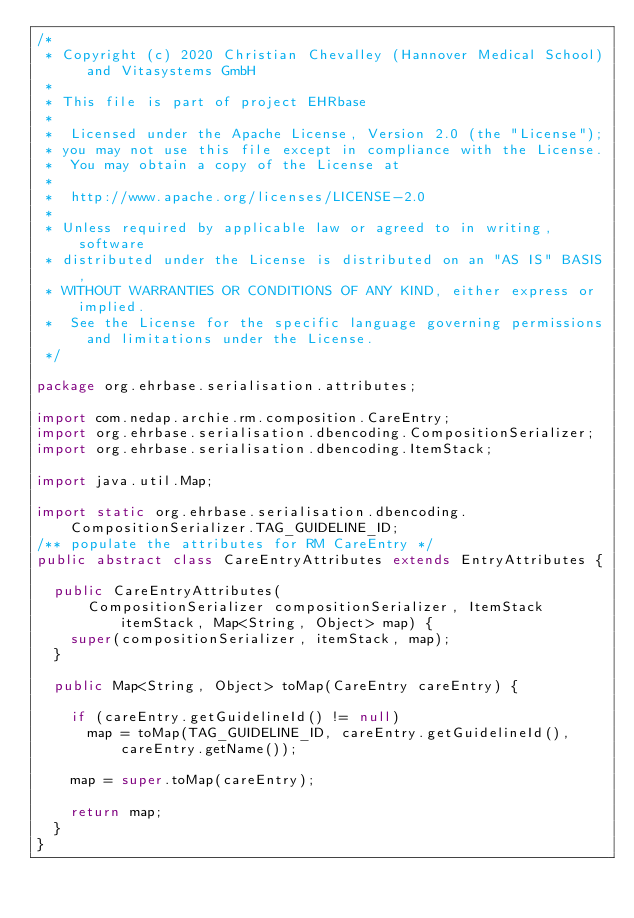<code> <loc_0><loc_0><loc_500><loc_500><_Java_>/*
 * Copyright (c) 2020 Christian Chevalley (Hannover Medical School) and Vitasystems GmbH
 *
 * This file is part of project EHRbase
 *
 *  Licensed under the Apache License, Version 2.0 (the "License");
 * you may not use this file except in compliance with the License.
 *  You may obtain a copy of the License at
 *
 *  http://www.apache.org/licenses/LICENSE-2.0
 *
 * Unless required by applicable law or agreed to in writing, software
 * distributed under the License is distributed on an "AS IS" BASIS,
 * WITHOUT WARRANTIES OR CONDITIONS OF ANY KIND, either express or implied.
 *  See the License for the specific language governing permissions and limitations under the License.
 */

package org.ehrbase.serialisation.attributes;

import com.nedap.archie.rm.composition.CareEntry;
import org.ehrbase.serialisation.dbencoding.CompositionSerializer;
import org.ehrbase.serialisation.dbencoding.ItemStack;

import java.util.Map;

import static org.ehrbase.serialisation.dbencoding.CompositionSerializer.TAG_GUIDELINE_ID;
/** populate the attributes for RM CareEntry */
public abstract class CareEntryAttributes extends EntryAttributes {

  public CareEntryAttributes(
      CompositionSerializer compositionSerializer, ItemStack itemStack, Map<String, Object> map) {
    super(compositionSerializer, itemStack, map);
  }

  public Map<String, Object> toMap(CareEntry careEntry) {

    if (careEntry.getGuidelineId() != null)
      map = toMap(TAG_GUIDELINE_ID, careEntry.getGuidelineId(), careEntry.getName());

    map = super.toMap(careEntry);

    return map;
  }
}
</code> 